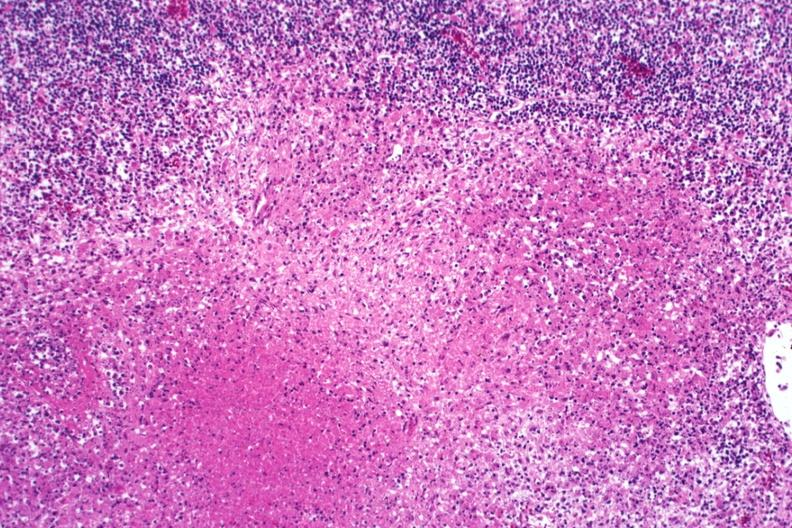s absence of palpebral fissure cleft palate present?
Answer the question using a single word or phrase. No 